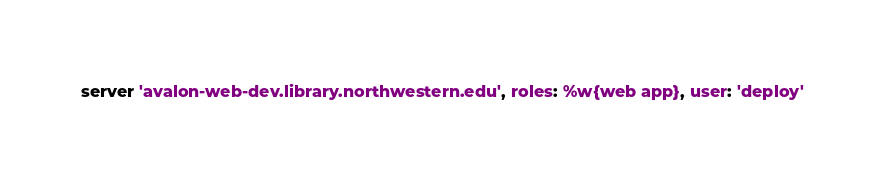Convert code to text. <code><loc_0><loc_0><loc_500><loc_500><_Ruby_>server 'avalon-web-dev.library.northwestern.edu', roles: %w{web app}, user: 'deploy'
</code> 